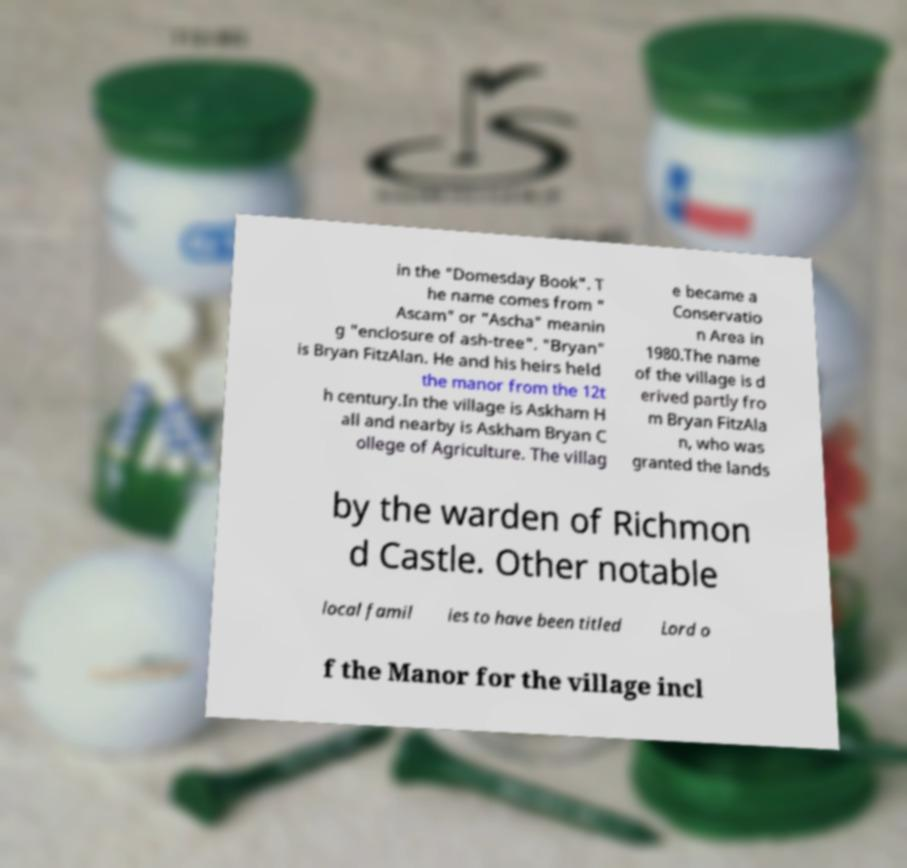For documentation purposes, I need the text within this image transcribed. Could you provide that? in the "Domesday Book". T he name comes from " Ascam" or "Ascha" meanin g "enclosure of ash-tree". "Bryan" is Bryan FitzAlan. He and his heirs held the manor from the 12t h century.In the village is Askham H all and nearby is Askham Bryan C ollege of Agriculture. The villag e became a Conservatio n Area in 1980.The name of the village is d erived partly fro m Bryan FitzAla n, who was granted the lands by the warden of Richmon d Castle. Other notable local famil ies to have been titled Lord o f the Manor for the village incl 